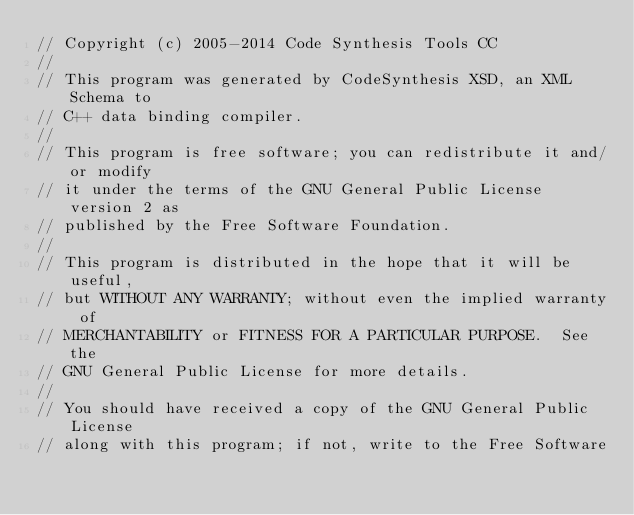<code> <loc_0><loc_0><loc_500><loc_500><_C++_>// Copyright (c) 2005-2014 Code Synthesis Tools CC
//
// This program was generated by CodeSynthesis XSD, an XML Schema to
// C++ data binding compiler.
//
// This program is free software; you can redistribute it and/or modify
// it under the terms of the GNU General Public License version 2 as
// published by the Free Software Foundation.
//
// This program is distributed in the hope that it will be useful,
// but WITHOUT ANY WARRANTY; without even the implied warranty of
// MERCHANTABILITY or FITNESS FOR A PARTICULAR PURPOSE.  See the
// GNU General Public License for more details.
//
// You should have received a copy of the GNU General Public License
// along with this program; if not, write to the Free Software</code> 